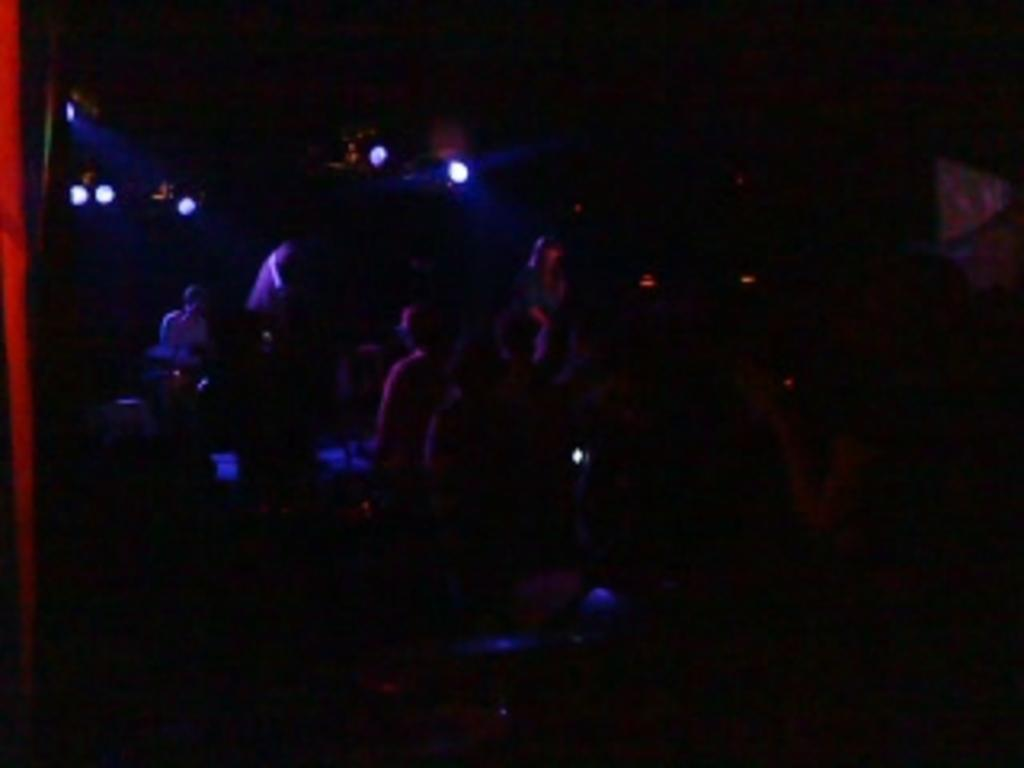What is the person in the image doing? There is a person sitting on a chair in the image. What can be seen on the left side of the image? There are lights on the left side of the image. Where are the other people in the image located? There are people on the floor in the image. What type of pen is the person using to write on the coat in the image? There is no pen or coat present in the image. 